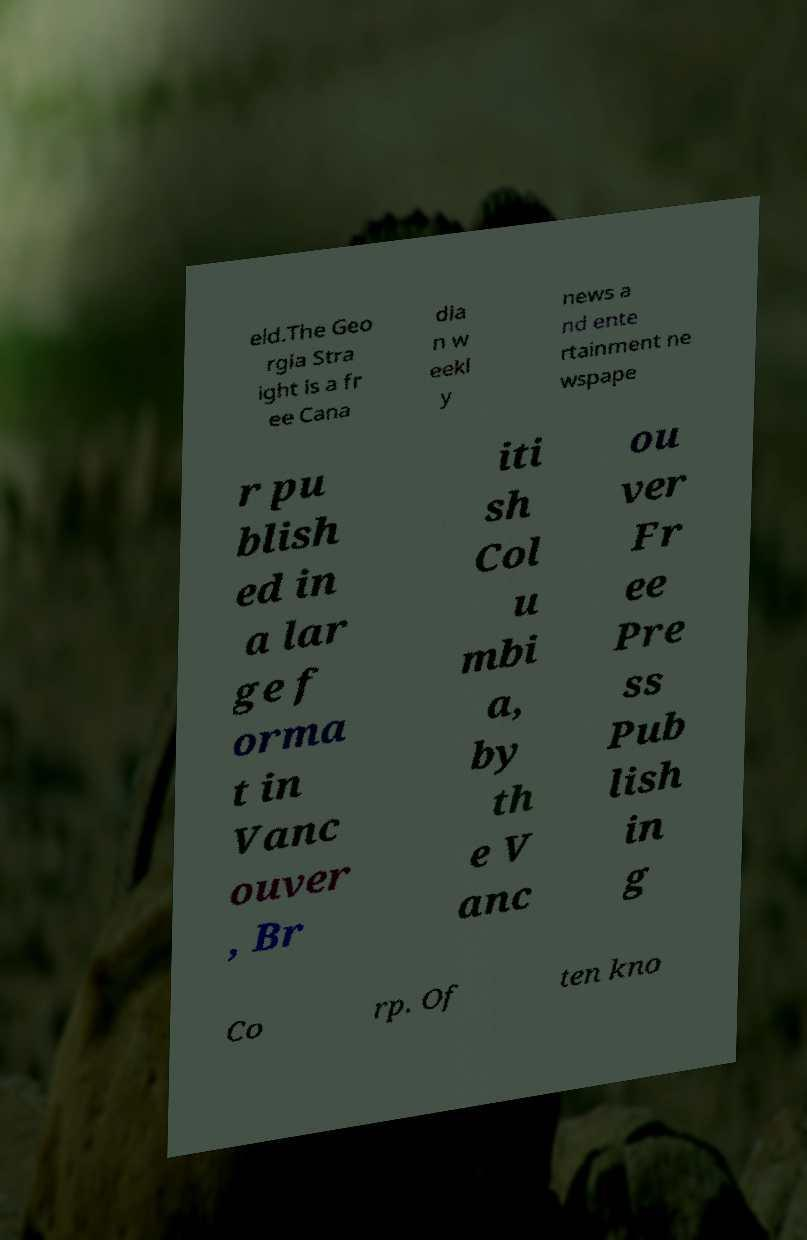Could you extract and type out the text from this image? eld.The Geo rgia Stra ight is a fr ee Cana dia n w eekl y news a nd ente rtainment ne wspape r pu blish ed in a lar ge f orma t in Vanc ouver , Br iti sh Col u mbi a, by th e V anc ou ver Fr ee Pre ss Pub lish in g Co rp. Of ten kno 